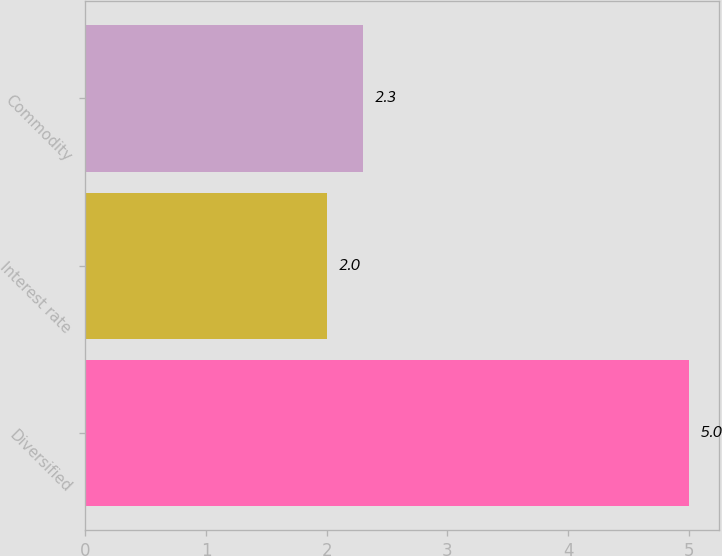Convert chart to OTSL. <chart><loc_0><loc_0><loc_500><loc_500><bar_chart><fcel>Diversified<fcel>Interest rate<fcel>Commodity<nl><fcel>5<fcel>2<fcel>2.3<nl></chart> 